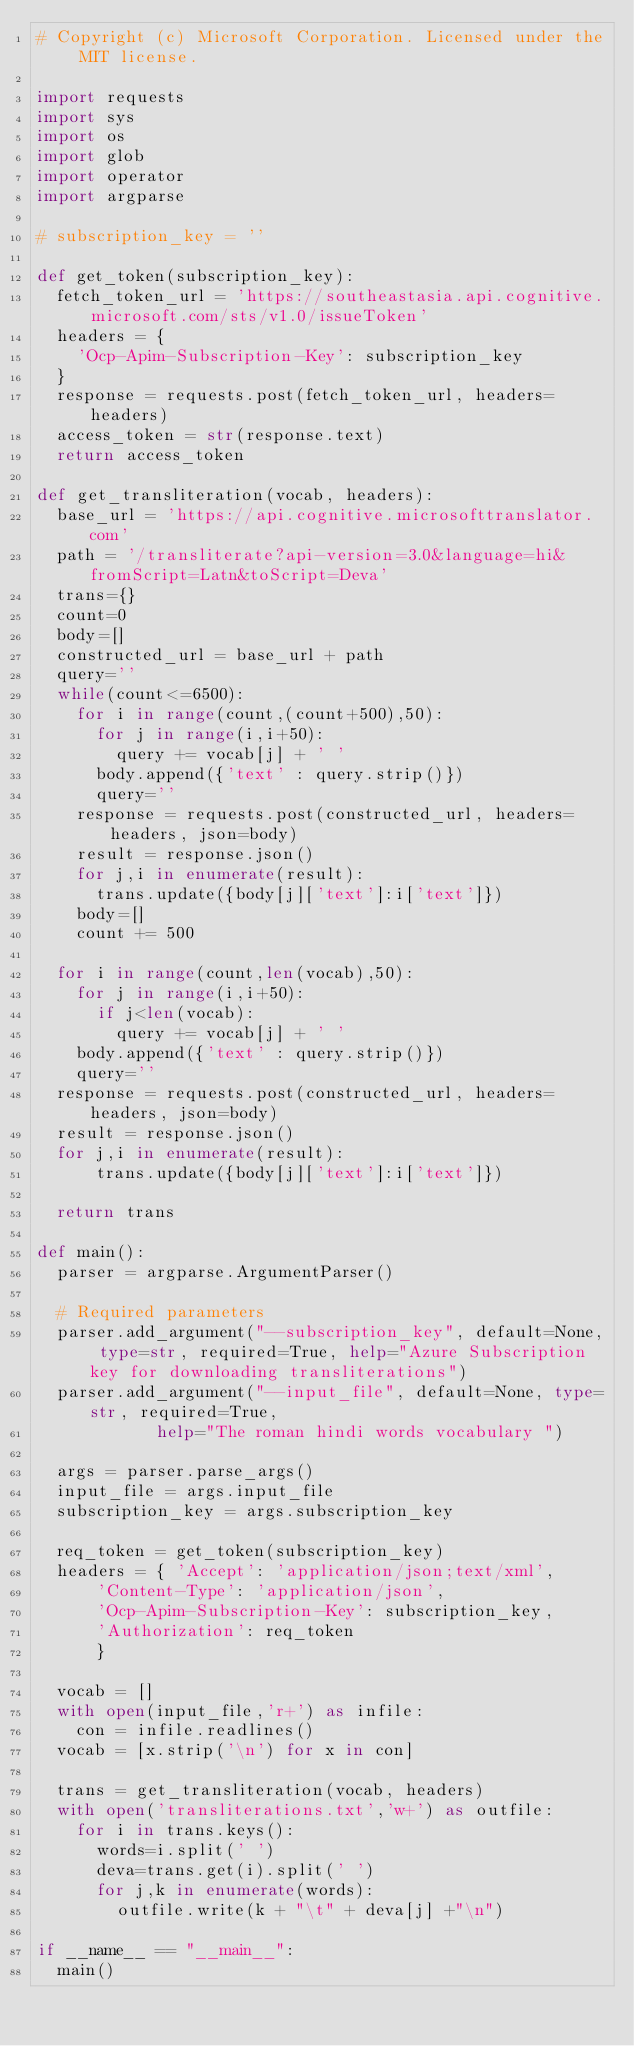Convert code to text. <code><loc_0><loc_0><loc_500><loc_500><_Python_># Copyright (c) Microsoft Corporation. Licensed under the MIT license.

import requests
import sys
import os
import glob
import operator
import argparse

# subscription_key = ''

def get_token(subscription_key):
	fetch_token_url = 'https://southeastasia.api.cognitive.microsoft.com/sts/v1.0/issueToken'
	headers = {
		'Ocp-Apim-Subscription-Key': subscription_key
	}
	response = requests.post(fetch_token_url, headers=headers)
	access_token = str(response.text)
	return access_token

def get_transliteration(vocab, headers):
	base_url = 'https://api.cognitive.microsofttranslator.com'
	path = '/transliterate?api-version=3.0&language=hi&fromScript=Latn&toScript=Deva'
	trans={}
	count=0
	body=[]
	constructed_url = base_url + path
	query=''
	while(count<=6500):
		for i in range(count,(count+500),50):
			for j in range(i,i+50):
				query += vocab[j] + ' '
			body.append({'text' : query.strip()})
			query=''
		response = requests.post(constructed_url, headers=headers, json=body)
		result = response.json()
		for j,i in enumerate(result):
			trans.update({body[j]['text']:i['text']})
		body=[]
		count += 500
	
	for i in range(count,len(vocab),50):
		for j in range(i,i+50):
			if j<len(vocab):
				query += vocab[j] + ' '
		body.append({'text' : query.strip()})
		query=''
	response = requests.post(constructed_url, headers=headers, json=body)
	result = response.json()
	for j,i in enumerate(result):
			trans.update({body[j]['text']:i['text']})
	
	return trans

def main():
	parser = argparse.ArgumentParser()

	# Required parameters
	parser.add_argument("--subscription_key", default=None, type=str, required=True, help="Azure Subscription key for downloading transliterations")
	parser.add_argument("--input_file", default=None, type=str, required=True,
						help="The roman hindi words vocabulary ")
	
	args = parser.parse_args()
	input_file = args.input_file
	subscription_key = args.subscription_key

	req_token = get_token(subscription_key)
	headers = { 'Accept': 'application/json;text/xml',
			'Content-Type': 'application/json',
			'Ocp-Apim-Subscription-Key': subscription_key,
			'Authorization': req_token
			}

	vocab = []
	with open(input_file,'r+') as infile:
		con = infile.readlines()
	vocab = [x.strip('\n') for x in con]

	trans = get_transliteration(vocab, headers)
	with open('transliterations.txt','w+') as outfile:
		for i in trans.keys():
			words=i.split(' ')
			deva=trans.get(i).split(' ')
			for j,k in enumerate(words):
				outfile.write(k + "\t" + deva[j] +"\n")

if __name__ == "__main__":
	main()</code> 